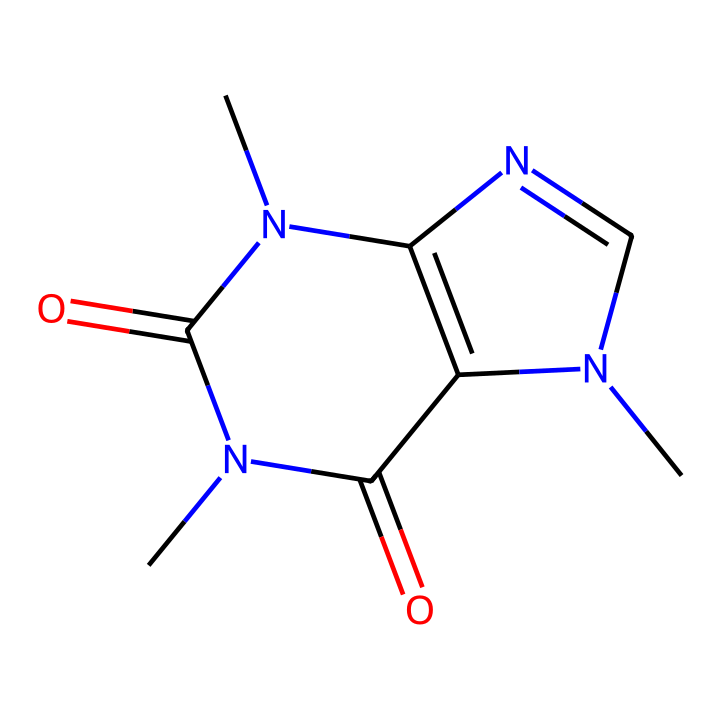What is the molecular formula for caffeine? The SMILES representation indicates the atoms present in the molecule: carbon (C), nitrogen (N), and oxygen (O). Counting these gives us a formula of C8H10N4O2.
Answer: C8H10N4O2 How many nitrogen atoms are in caffeine? In the provided SMILES, the 'N' indicates nitrogen atoms. There are four 'N' characters present, indicating there are four nitrogen atoms in the molecule.
Answer: 4 What is the total number of carbon atoms in caffeine? By analyzing the SMILES, every 'C' in the structure counts as a carbon atom. There are eight instances of 'C' in the representation, determining that caffeine has eight carbon atoms.
Answer: 8 What type of compound is caffeine classified as? Caffeine has complex structural characteristics but is primarily recognized for having a nitrogenous base characteristic of alkaloids, which often exhibit stimulant properties. This classification links to its common occurrence in plants.
Answer: alkaloid How many rings are present in the structure of caffeine? The chemical structure shows interconnected cycles; upon examining the visualization from the SMILES, it is apparent that there are two fused rings forming the core of the caffeine structure.
Answer: 2 Which functional group is prominent in caffeine? The structure indicates the presence of carbonyl groups (C=O) as observed from the carbon atoms bonded to oxygen. In caffeine, these carbonyl groups are significant for its reactivity and properties.
Answer: carbonyl Is caffeine a polar or non-polar molecule? Analyzing the structure reveals multiple oxygen atoms and nitrogen, contributing to its polar character due to their electronegativity. The presence of these highly electronegative atoms typically increases the polarity of the molecule.
Answer: polar 